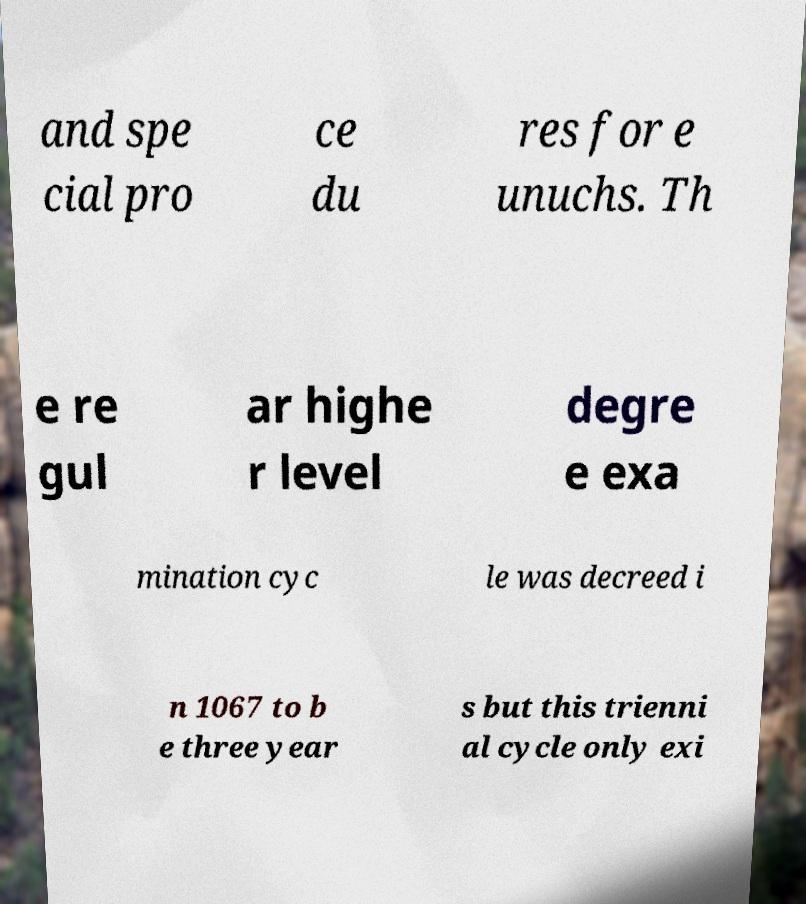Please identify and transcribe the text found in this image. and spe cial pro ce du res for e unuchs. Th e re gul ar highe r level degre e exa mination cyc le was decreed i n 1067 to b e three year s but this trienni al cycle only exi 